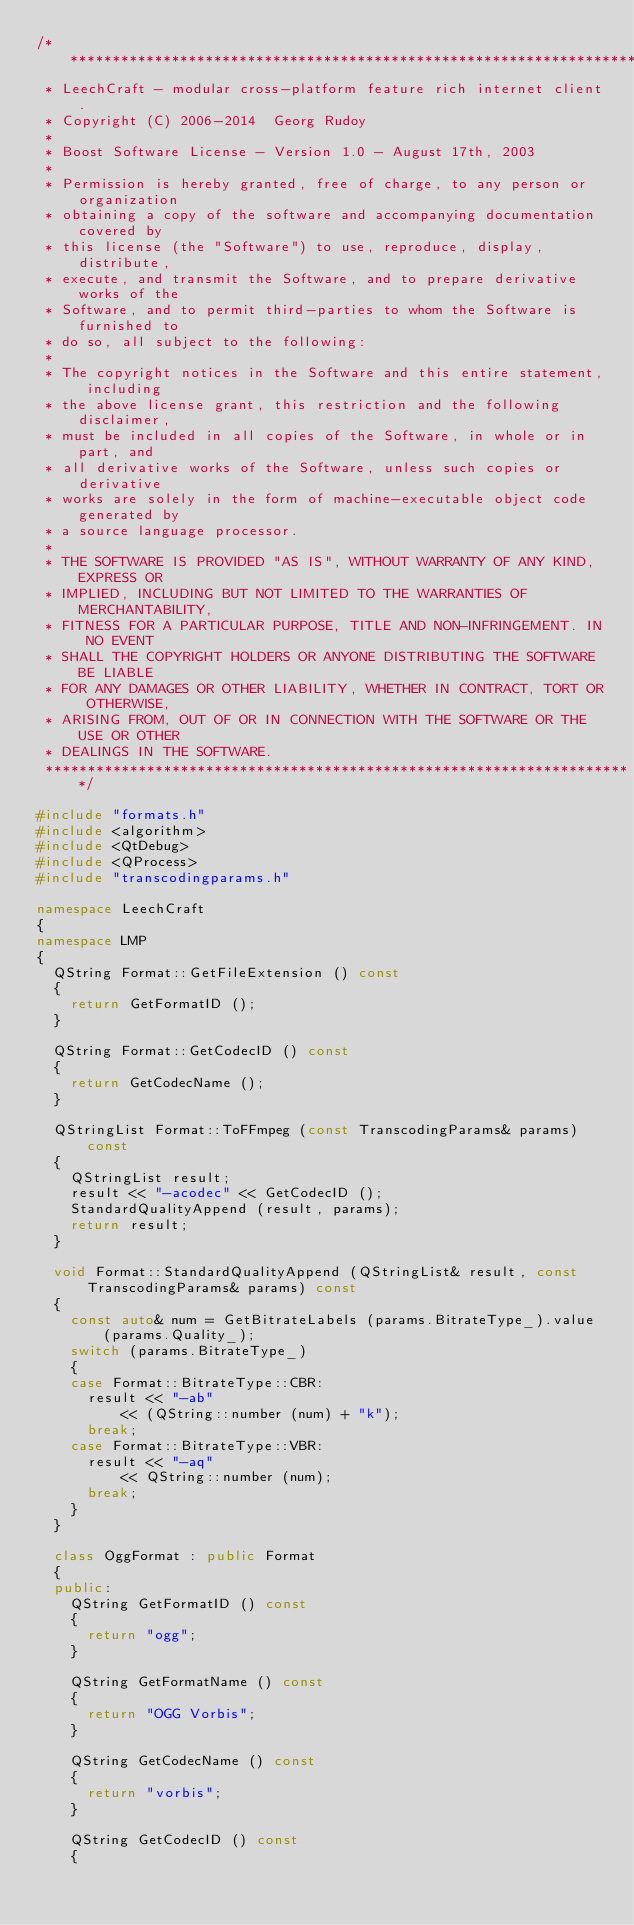Convert code to text. <code><loc_0><loc_0><loc_500><loc_500><_C++_>/**********************************************************************
 * LeechCraft - modular cross-platform feature rich internet client.
 * Copyright (C) 2006-2014  Georg Rudoy
 *
 * Boost Software License - Version 1.0 - August 17th, 2003
 *
 * Permission is hereby granted, free of charge, to any person or organization
 * obtaining a copy of the software and accompanying documentation covered by
 * this license (the "Software") to use, reproduce, display, distribute,
 * execute, and transmit the Software, and to prepare derivative works of the
 * Software, and to permit third-parties to whom the Software is furnished to
 * do so, all subject to the following:
 *
 * The copyright notices in the Software and this entire statement, including
 * the above license grant, this restriction and the following disclaimer,
 * must be included in all copies of the Software, in whole or in part, and
 * all derivative works of the Software, unless such copies or derivative
 * works are solely in the form of machine-executable object code generated by
 * a source language processor.
 *
 * THE SOFTWARE IS PROVIDED "AS IS", WITHOUT WARRANTY OF ANY KIND, EXPRESS OR
 * IMPLIED, INCLUDING BUT NOT LIMITED TO THE WARRANTIES OF MERCHANTABILITY,
 * FITNESS FOR A PARTICULAR PURPOSE, TITLE AND NON-INFRINGEMENT. IN NO EVENT
 * SHALL THE COPYRIGHT HOLDERS OR ANYONE DISTRIBUTING THE SOFTWARE BE LIABLE
 * FOR ANY DAMAGES OR OTHER LIABILITY, WHETHER IN CONTRACT, TORT OR OTHERWISE,
 * ARISING FROM, OUT OF OR IN CONNECTION WITH THE SOFTWARE OR THE USE OR OTHER
 * DEALINGS IN THE SOFTWARE.
 **********************************************************************/

#include "formats.h"
#include <algorithm>
#include <QtDebug>
#include <QProcess>
#include "transcodingparams.h"

namespace LeechCraft
{
namespace LMP
{
	QString Format::GetFileExtension () const
	{
		return GetFormatID ();
	}

	QString Format::GetCodecID () const
	{
		return GetCodecName ();
	}

	QStringList Format::ToFFmpeg (const TranscodingParams& params) const
	{
		QStringList result;
		result << "-acodec" << GetCodecID ();
		StandardQualityAppend (result, params);
		return result;
	}

	void Format::StandardQualityAppend (QStringList& result, const TranscodingParams& params) const
	{
		const auto& num = GetBitrateLabels (params.BitrateType_).value (params.Quality_);
		switch (params.BitrateType_)
		{
		case Format::BitrateType::CBR:
			result << "-ab"
					<< (QString::number (num) + "k");
			break;
		case Format::BitrateType::VBR:
			result << "-aq"
					<< QString::number (num);
			break;
		}
	}

	class OggFormat : public Format
	{
	public:
		QString GetFormatID () const
		{
			return "ogg";
		}

		QString GetFormatName () const
		{
			return "OGG Vorbis";
		}

		QString GetCodecName () const
		{
			return "vorbis";
		}

		QString GetCodecID () const
		{</code> 